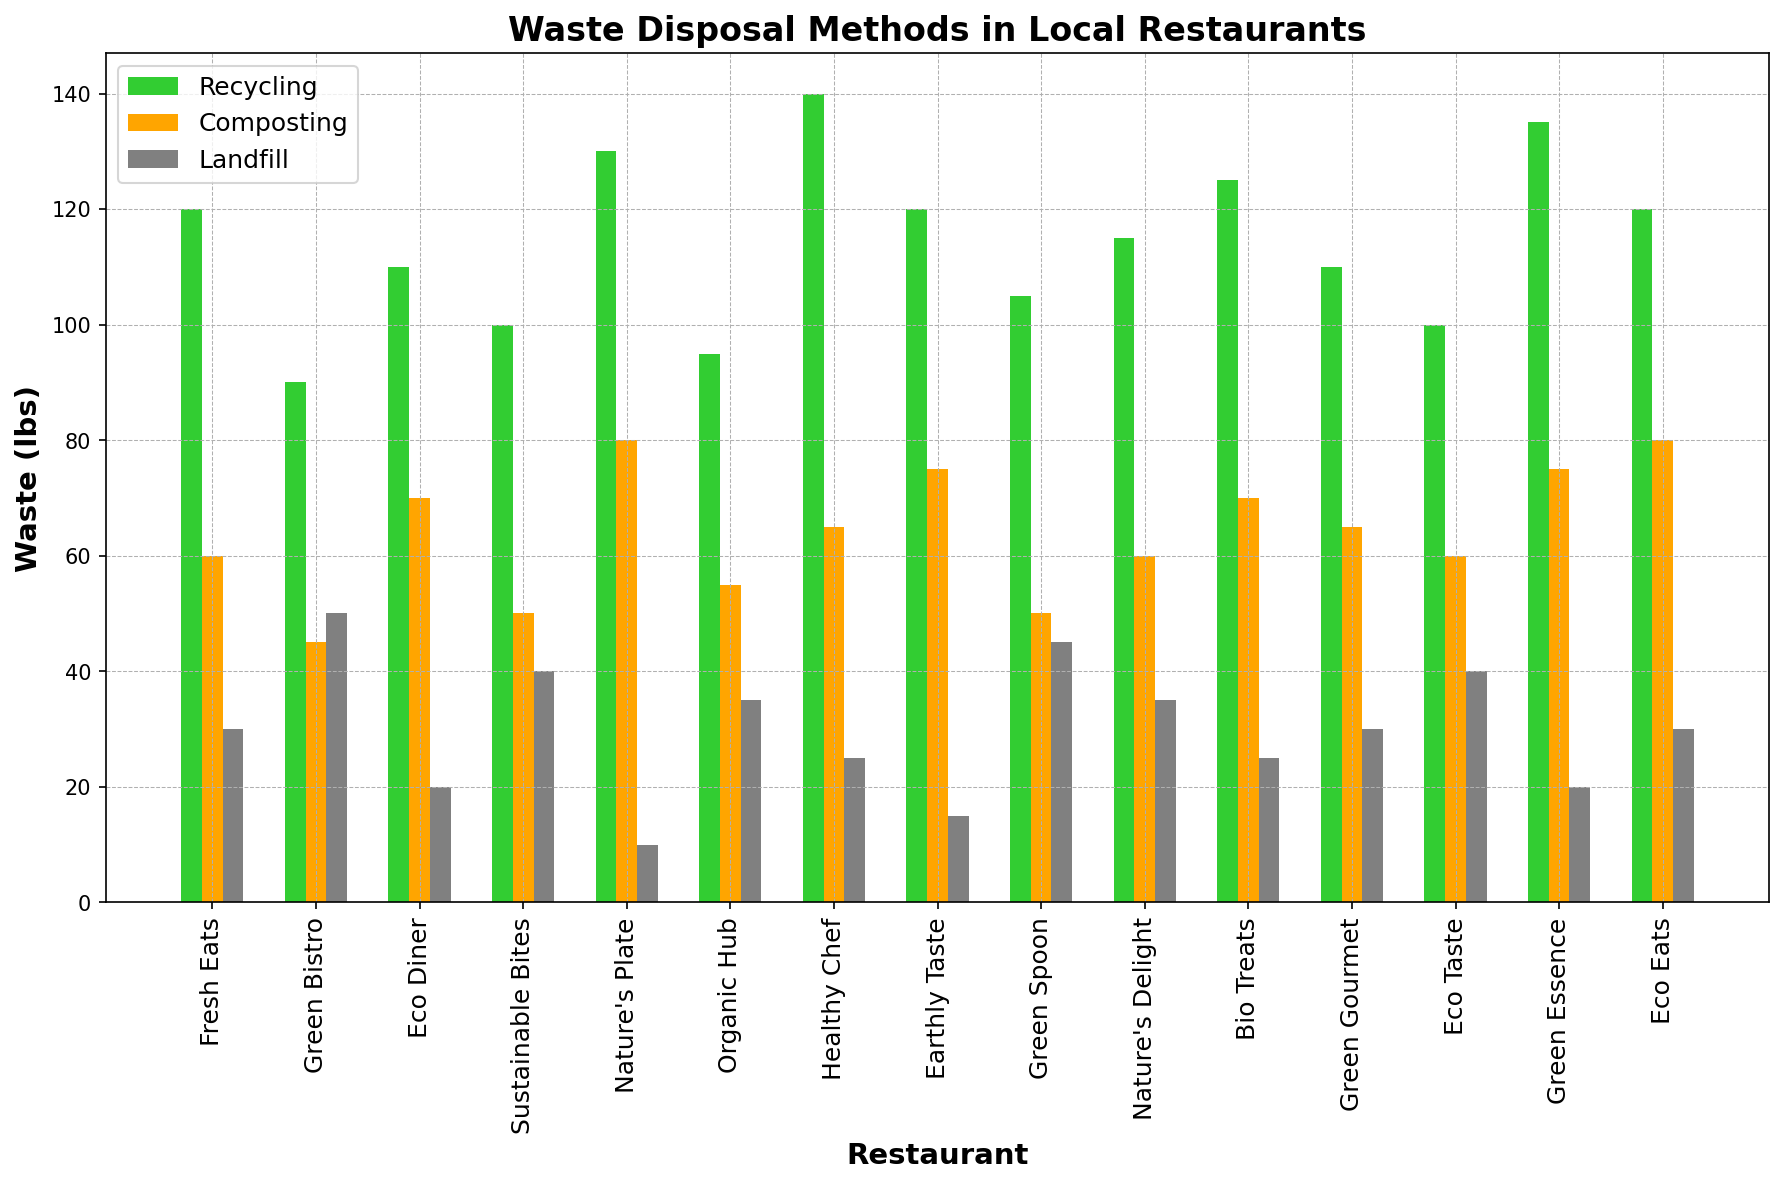What restaurant has the highest amount of recycling waste? Look for the bar corresponding to "Recycling (lbs)" which is the tallest. "Healthy Chef" has the highest recycling amount with 140 lbs.
Answer: Healthy Chef Which restaurant has the least amount of landfill waste? Identify the smallest bar in the "Landfill (lbs)" category. "Nature's Plate" has the least landfill waste with 10 lbs.
Answer: Nature's Plate What is the total waste generated by Eco Eats? Sum the bars for "Recycling (lbs)", "Composting (lbs)", and "Landfill (lbs)" for Eco Eats: 120 + 80 + 30 = 230 lbs.
Answer: 230 lbs Which restaurant has a higher composting waste: Earthly Taste or Green Spoon? Compare the height of the "Composting (lbs)" bars for Earthly Taste (75 lbs) and Green Spoon (50 lbs).
Answer: Earthly Taste What is the average amount of recycling waste across all restaurants? Sum the recycling weights and divide by the number of restaurants: (120 + 90 + 110 + 100 + 130 + 95 + 140 + 120 + 105 + 115 + 125 + 110 + 100 + 135 + 120) / 15 = 112.67 lbs.
Answer: 112.67 lbs Which waste disposal method is the most used at Fresh Eats? Compare the heights of the bars for Fresh Eats. Recycling (120) and Composting (60) are higher than Landfill (30).
Answer: Recycling Is the amount of landfill waste for Bio Treats more than twice the amount of composting waste for Green Gourment? Compare 25 lbs of landfill waste for Bio Treats to 2 * 65 lbs of composting waste for Green Gourmet: 25 < 130.
Answer: No How much more recycling does Nature's Plate have compared to Eco Diner? Subtract Eco Diner's recycling (110 lbs) from Nature's Plate's recycling (130 lbs): 130 - 110 = 20 lbs.
Answer: 20 lbs Rank Eco Taste, Green Essence, and Bio Treats based on their composting waste from highest to lowest. Compare the composting amounts: Green Essence (75 lbs), Bio Treats (70 lbs), and Eco Taste (60 lbs), in descending order.
Answer: Green Essence, Bio Treats, Eco Taste What is the combined total of landfill waste for Green Bistro and Sustainable Bites? Add the landfill weights for Green Bistro (50 lbs) and Sustainable Bites (40 lbs): 50 + 40 = 90 lbs.
Answer: 90 lbs 